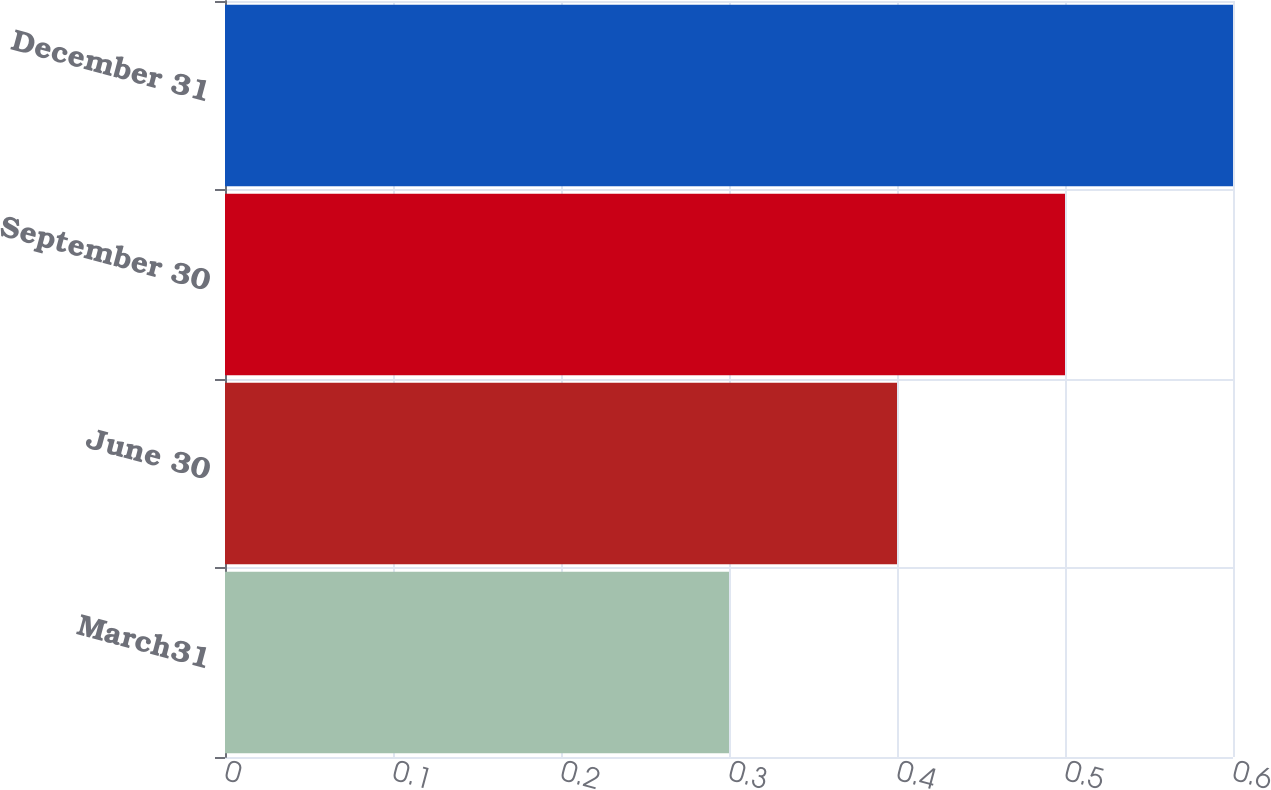Convert chart to OTSL. <chart><loc_0><loc_0><loc_500><loc_500><bar_chart><fcel>March31<fcel>June 30<fcel>September 30<fcel>December 31<nl><fcel>0.3<fcel>0.4<fcel>0.5<fcel>0.6<nl></chart> 